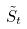Convert formula to latex. <formula><loc_0><loc_0><loc_500><loc_500>\tilde { S } _ { t }</formula> 